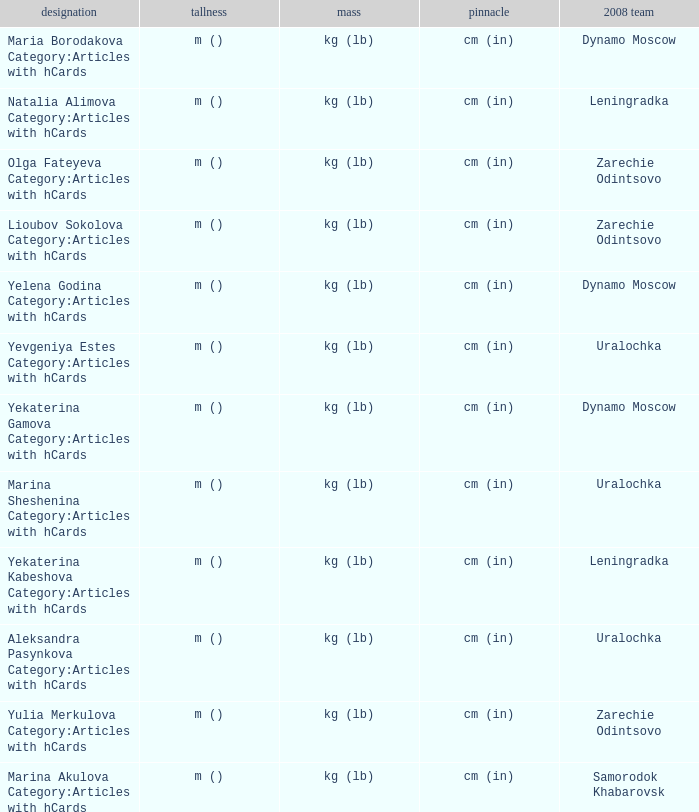What is the name when the 2008 club is zarechie odintsovo? Olga Fateyeva Category:Articles with hCards, Lioubov Sokolova Category:Articles with hCards, Yulia Merkulova Category:Articles with hCards. 